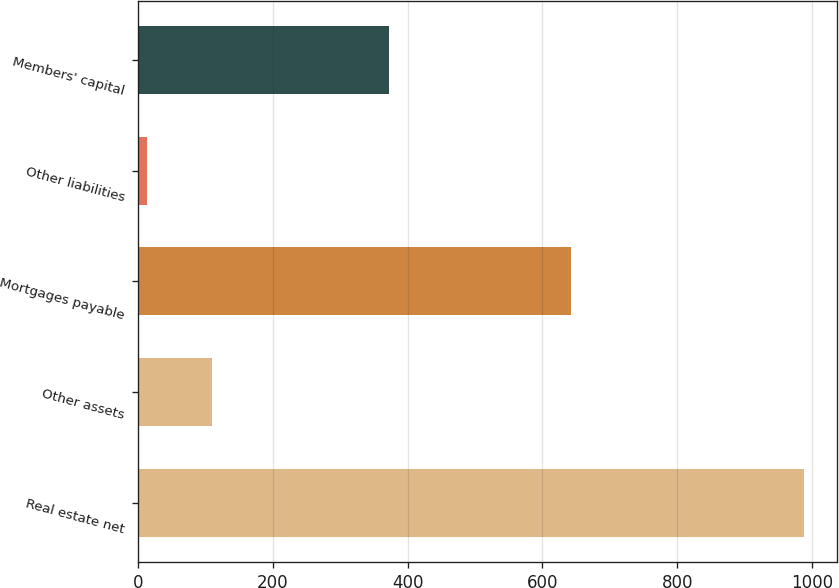Convert chart to OTSL. <chart><loc_0><loc_0><loc_500><loc_500><bar_chart><fcel>Real estate net<fcel>Other assets<fcel>Mortgages payable<fcel>Other liabilities<fcel>Members' capital<nl><fcel>987.4<fcel>110.53<fcel>642.6<fcel>13.1<fcel>372.4<nl></chart> 